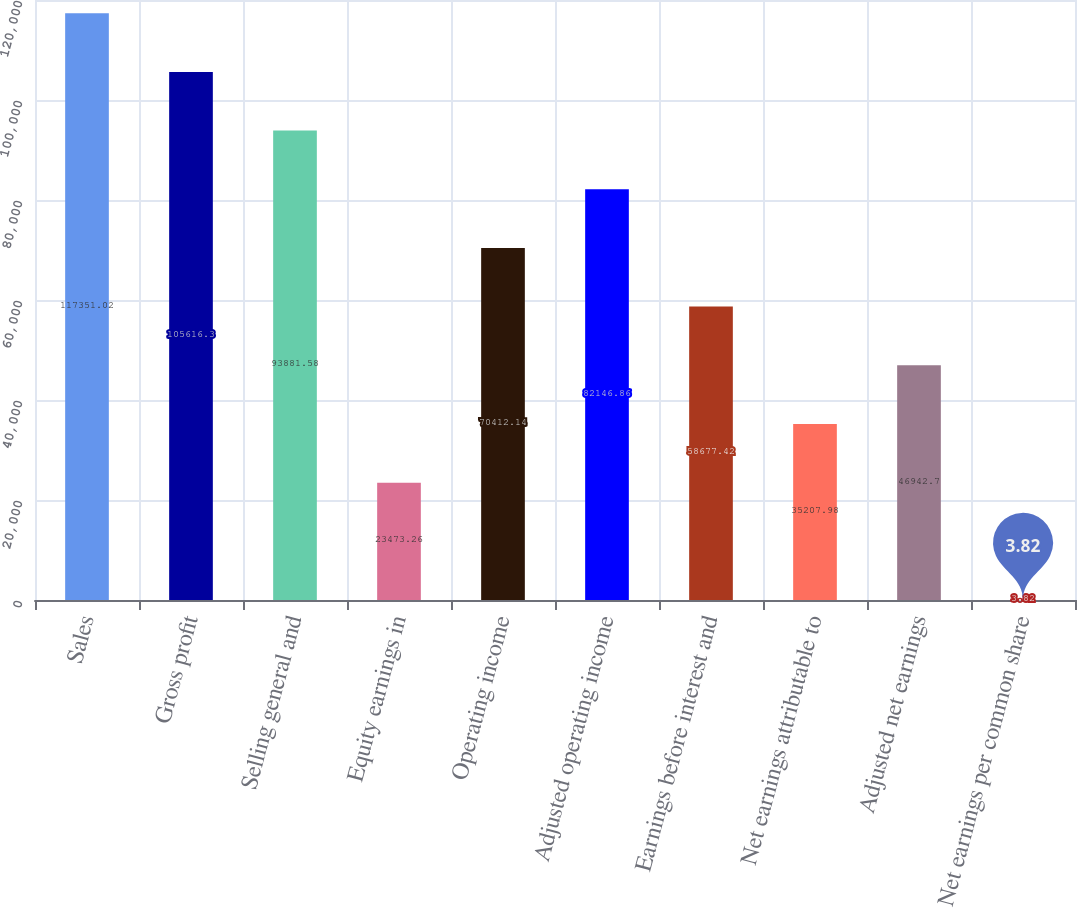Convert chart. <chart><loc_0><loc_0><loc_500><loc_500><bar_chart><fcel>Sales<fcel>Gross profit<fcel>Selling general and<fcel>Equity earnings in<fcel>Operating income<fcel>Adjusted operating income<fcel>Earnings before interest and<fcel>Net earnings attributable to<fcel>Adjusted net earnings<fcel>Net earnings per common share<nl><fcel>117351<fcel>105616<fcel>93881.6<fcel>23473.3<fcel>70412.1<fcel>82146.9<fcel>58677.4<fcel>35208<fcel>46942.7<fcel>3.82<nl></chart> 